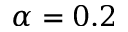Convert formula to latex. <formula><loc_0><loc_0><loc_500><loc_500>\alpha = 0 . 2</formula> 